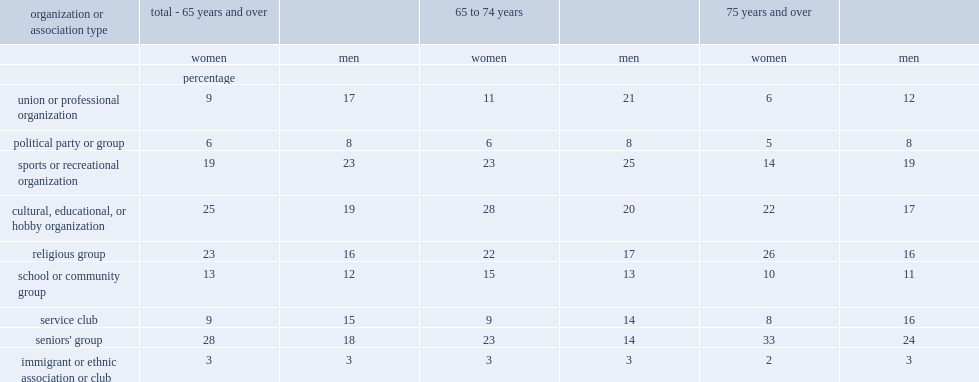List the top3 organization and association types reported by senior women and percentage respectively. Seniors' group cultural, educational, or hobby organization religious group. What's the percentage of women aged 75 and over participating in a seniors' group? 0.33. Which is more about participateions in a religious organization,older senior women or younger senior women. 75 years and over. Which is less about participations in a cultural, educational, or hobby organization,older senior women or younger senior women. 75 years and over. List the top 3 organization and association types reported by senior men and percentage respectively. Sports or recreational organization cultural, educational, or hobby organization seniors' group. 